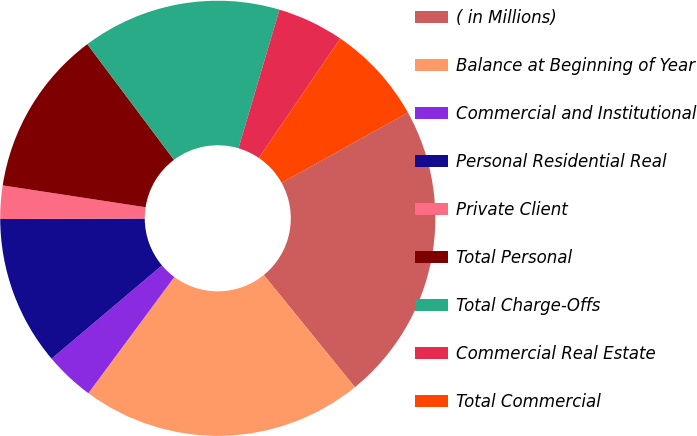Convert chart to OTSL. <chart><loc_0><loc_0><loc_500><loc_500><pie_chart><fcel>( in Millions)<fcel>Balance at Beginning of Year<fcel>Commercial and Institutional<fcel>Personal Residential Real<fcel>Private Client<fcel>Total Personal<fcel>Total Charge-Offs<fcel>Commercial Real Estate<fcel>Total Commercial<nl><fcel>22.22%<fcel>20.99%<fcel>3.7%<fcel>11.11%<fcel>2.47%<fcel>12.35%<fcel>14.81%<fcel>4.94%<fcel>7.41%<nl></chart> 